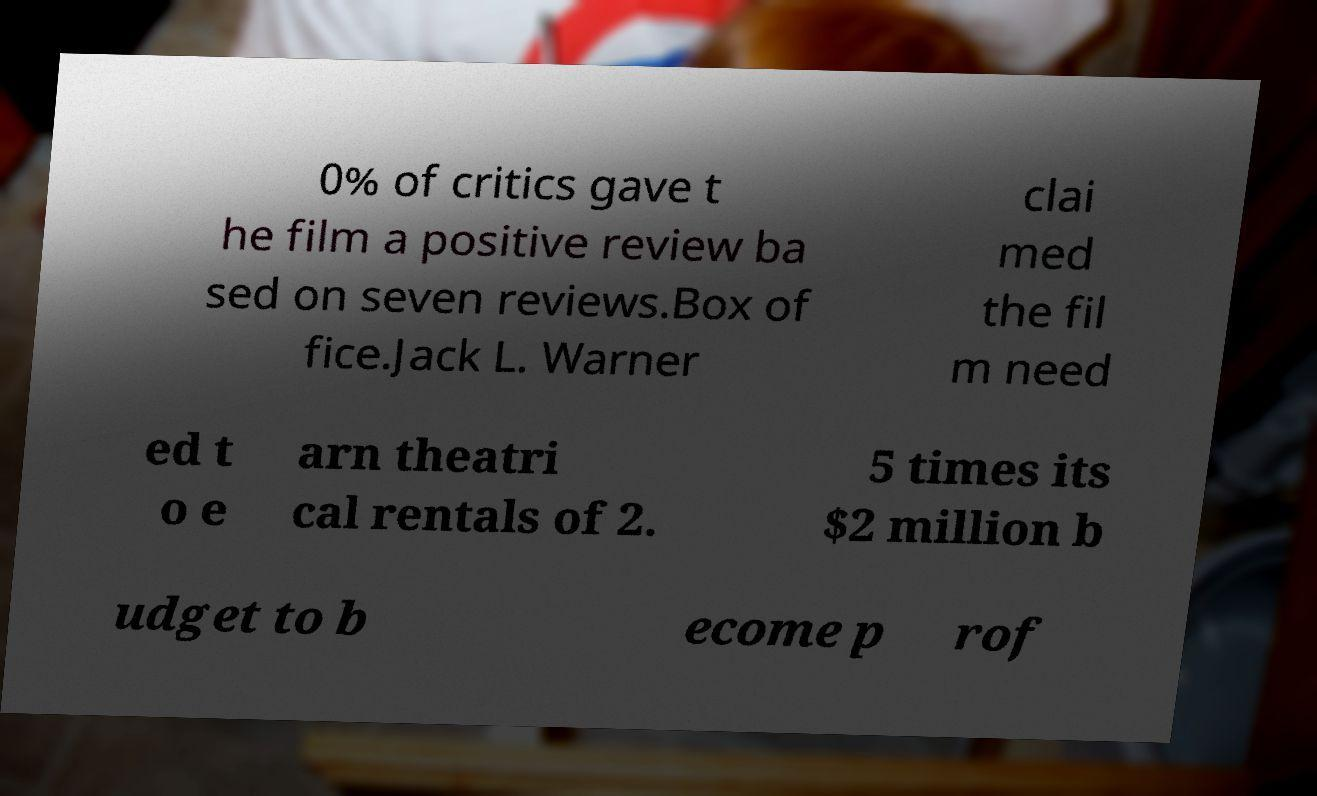I need the written content from this picture converted into text. Can you do that? 0% of critics gave t he film a positive review ba sed on seven reviews.Box of fice.Jack L. Warner clai med the fil m need ed t o e arn theatri cal rentals of 2. 5 times its $2 million b udget to b ecome p rof 